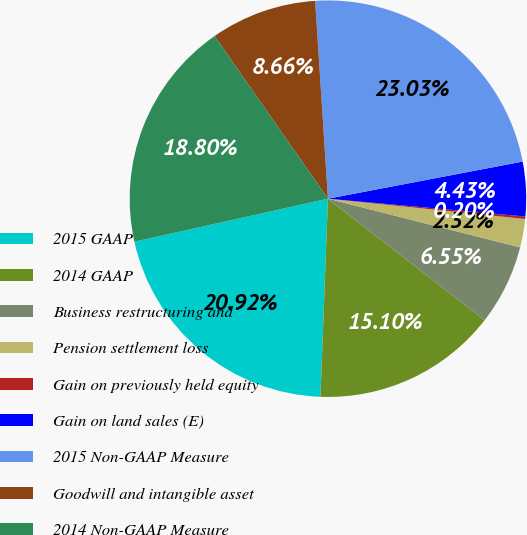Convert chart to OTSL. <chart><loc_0><loc_0><loc_500><loc_500><pie_chart><fcel>2015 GAAP<fcel>2014 GAAP<fcel>Business restructuring and<fcel>Pension settlement loss<fcel>Gain on previously held equity<fcel>Gain on land sales (E)<fcel>2015 Non-GAAP Measure<fcel>Goodwill and intangible asset<fcel>2014 Non-GAAP Measure<nl><fcel>20.92%<fcel>15.1%<fcel>6.55%<fcel>2.32%<fcel>0.2%<fcel>4.43%<fcel>23.03%<fcel>8.66%<fcel>18.8%<nl></chart> 